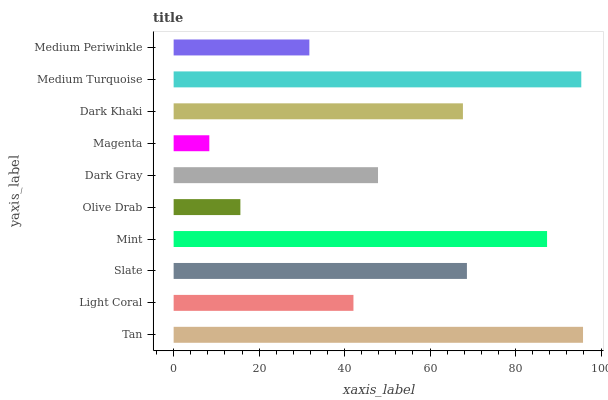Is Magenta the minimum?
Answer yes or no. Yes. Is Tan the maximum?
Answer yes or no. Yes. Is Light Coral the minimum?
Answer yes or no. No. Is Light Coral the maximum?
Answer yes or no. No. Is Tan greater than Light Coral?
Answer yes or no. Yes. Is Light Coral less than Tan?
Answer yes or no. Yes. Is Light Coral greater than Tan?
Answer yes or no. No. Is Tan less than Light Coral?
Answer yes or no. No. Is Dark Khaki the high median?
Answer yes or no. Yes. Is Dark Gray the low median?
Answer yes or no. Yes. Is Slate the high median?
Answer yes or no. No. Is Light Coral the low median?
Answer yes or no. No. 